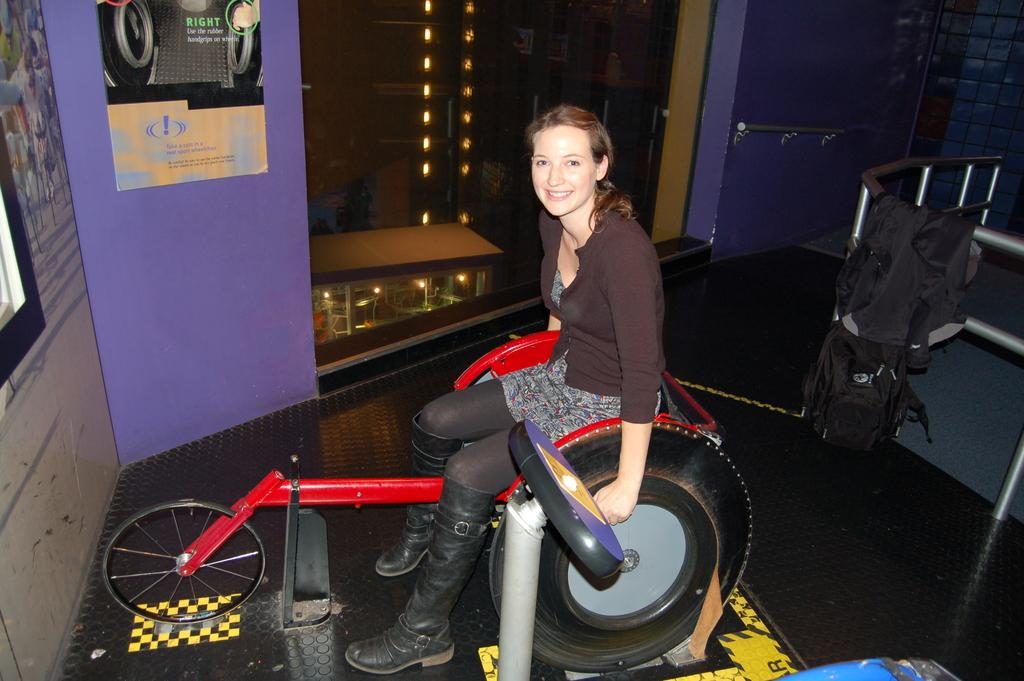Who is present in the image? There is a woman in the image. What is the woman doing in the image? The woman is sitting and cycling. What is the woman's facial expression in the image? The woman is smiling in the image. What can be seen in the background of the image? There are lights visible in the image, as well as a wall with pictures on it. What type of rod is being used by the passenger in the image? There is no passenger or rod present in the image; it features a woman sitting and cycling. How much sand can be seen on the ground in the image? There is no sand visible in the image; it features a woman sitting and cycling, lights, and a wall with pictures on it. 